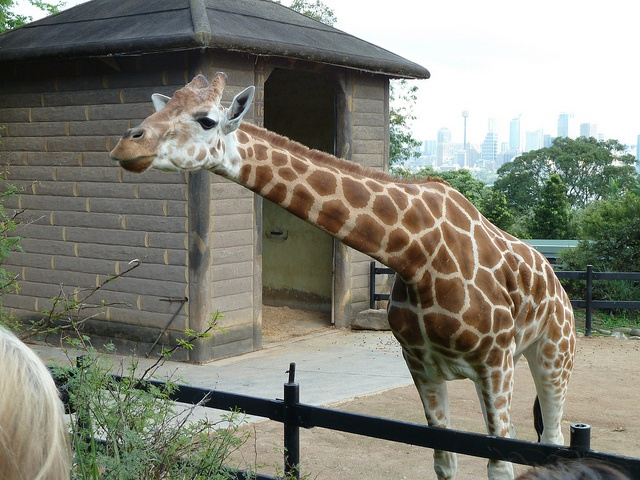Describe the objects in this image and their specific colors. I can see giraffe in green, gray, darkgray, and maroon tones, people in green, darkgray, gray, and lightgray tones, and people in green, gray, and black tones in this image. 